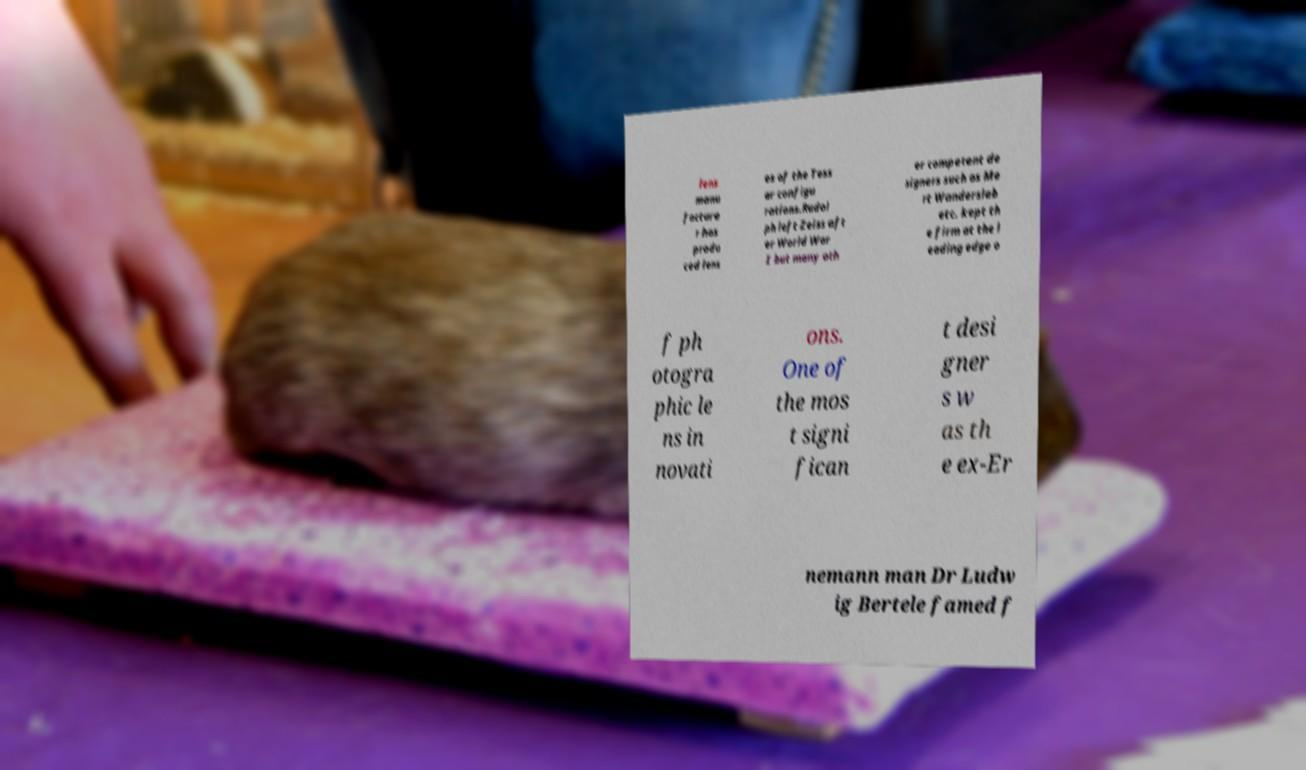Could you assist in decoding the text presented in this image and type it out clearly? lens manu facture r has produ ced lens es of the Tess ar configu rations.Rudol ph left Zeiss aft er World War I but many oth er competent de signers such as Me rt Wandersleb etc. kept th e firm at the l eading edge o f ph otogra phic le ns in novati ons. One of the mos t signi fican t desi gner s w as th e ex-Er nemann man Dr Ludw ig Bertele famed f 